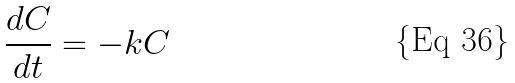<formula> <loc_0><loc_0><loc_500><loc_500>\frac { d C } { d t } = - k C</formula> 